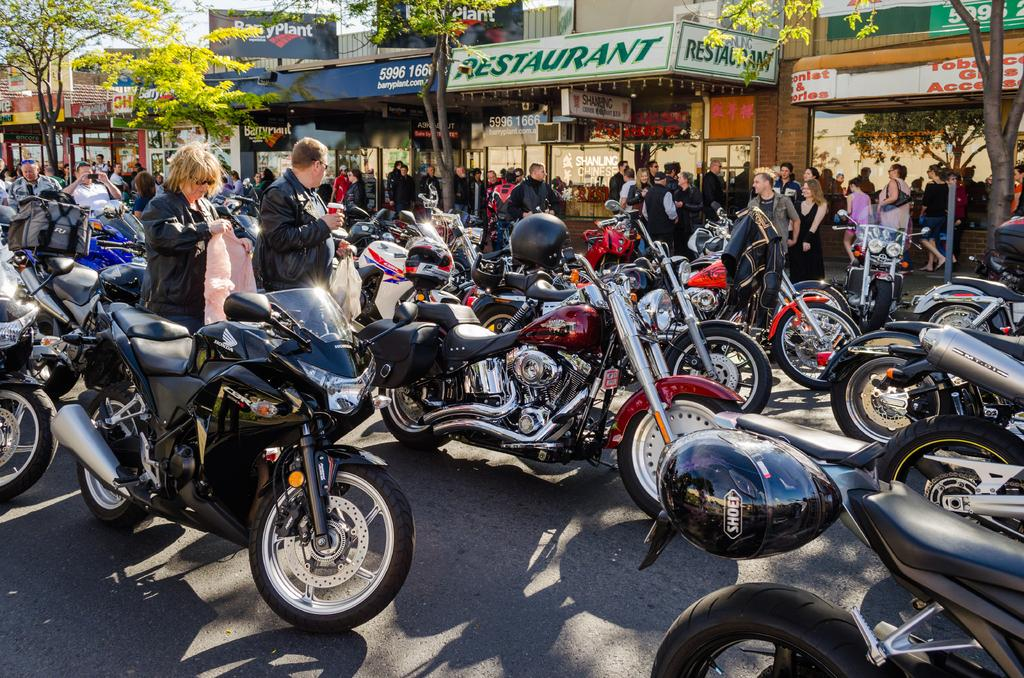What type of vehicles are present in the image? There are bikes in the image. What safety equipment is visible in the image? There are helmets in the image. What clothing items can be seen in the image? There are jackets in the image. Who is present in the image? There are people in the image. What are the people holding in the image? The people are holding something, but the facts do not specify what they are holding. What type of establishments can be seen in the image? There are stores in the image. What type of natural elements are present in the image? There are trees in the image. What type of juice is being served at the stores in the image? There is no mention of juice or any type of beverage being served in the image. What day of the week is it in the image? The facts provided do not give any information about the day of the week. 